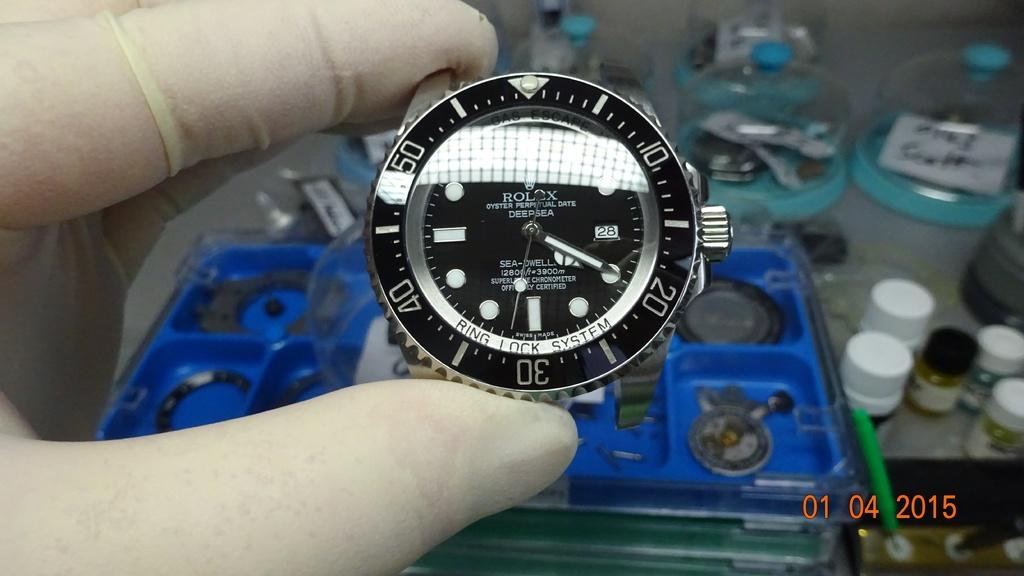Provide a one-sentence caption for the provided image. "Rolex Oyster Perpetual Date Deep Sea" is branded onto this watch. 